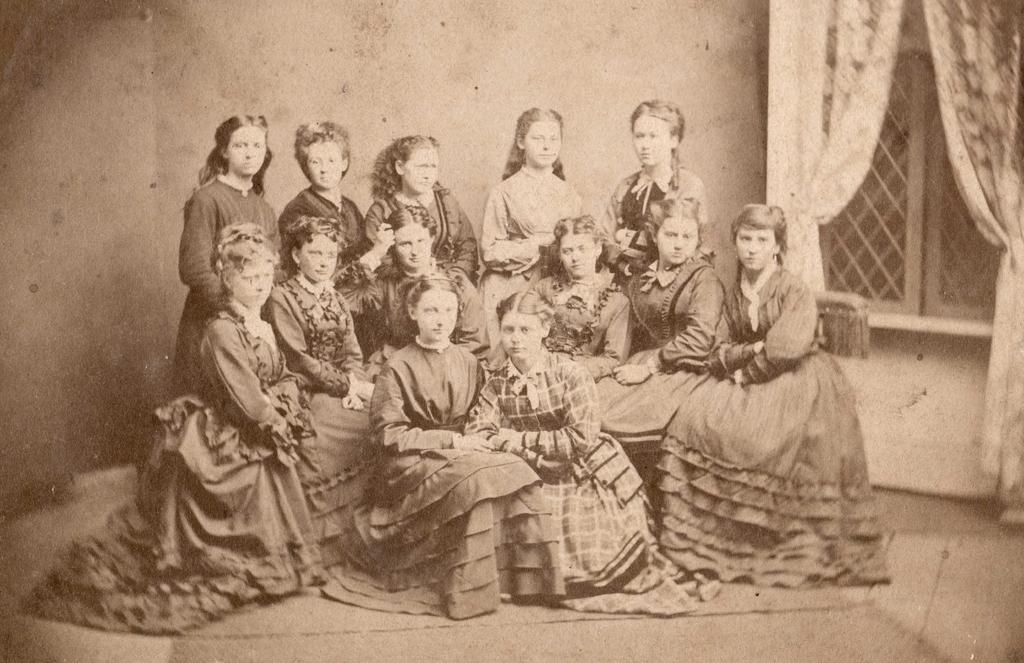Please provide a concise description of this image. In this image there are many girls in one frame some are sitting and some are standing. 